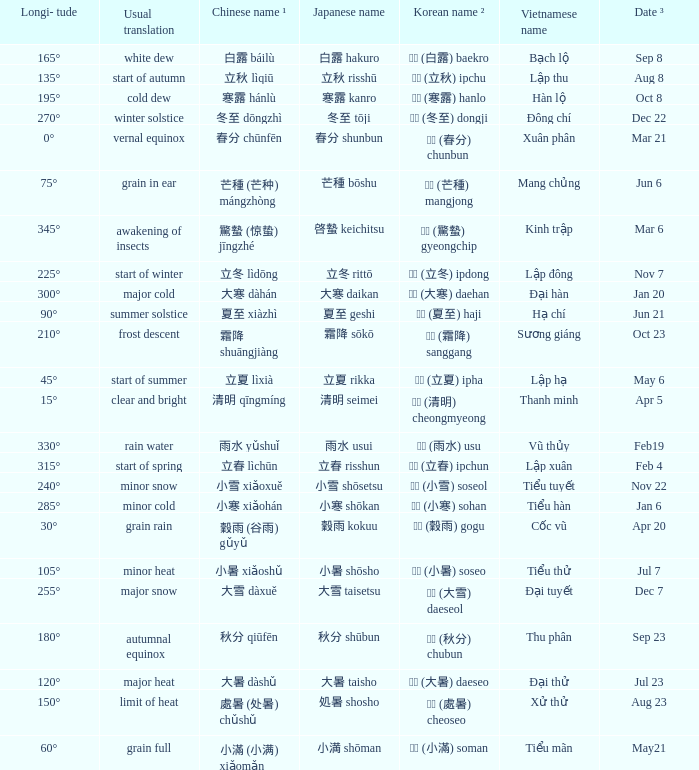Which Japanese name has a Korean name ² of 경칩 (驚蟄) gyeongchip? 啓蟄 keichitsu. 